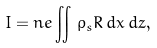<formula> <loc_0><loc_0><loc_500><loc_500>I = n e \iint \, \rho _ { s } R \, d x \, d z ,</formula> 